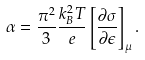Convert formula to latex. <formula><loc_0><loc_0><loc_500><loc_500>\alpha = \frac { \pi ^ { 2 } } { 3 } \frac { k _ { B } ^ { 2 } T } { e } \left [ \frac { \partial \sigma } { \partial \epsilon } \right ] _ { \mu } .</formula> 